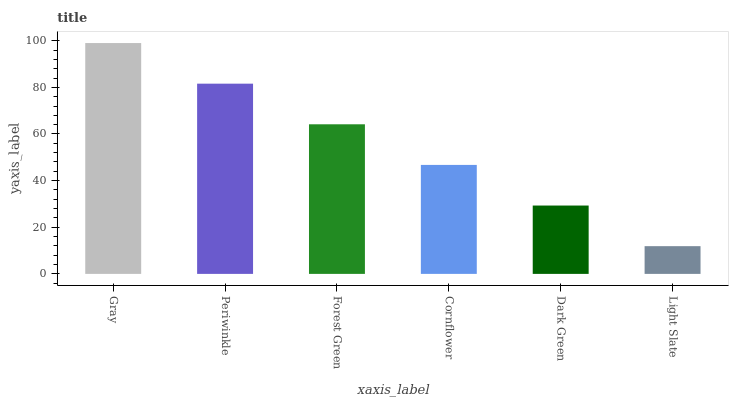Is Light Slate the minimum?
Answer yes or no. Yes. Is Gray the maximum?
Answer yes or no. Yes. Is Periwinkle the minimum?
Answer yes or no. No. Is Periwinkle the maximum?
Answer yes or no. No. Is Gray greater than Periwinkle?
Answer yes or no. Yes. Is Periwinkle less than Gray?
Answer yes or no. Yes. Is Periwinkle greater than Gray?
Answer yes or no. No. Is Gray less than Periwinkle?
Answer yes or no. No. Is Forest Green the high median?
Answer yes or no. Yes. Is Cornflower the low median?
Answer yes or no. Yes. Is Periwinkle the high median?
Answer yes or no. No. Is Gray the low median?
Answer yes or no. No. 